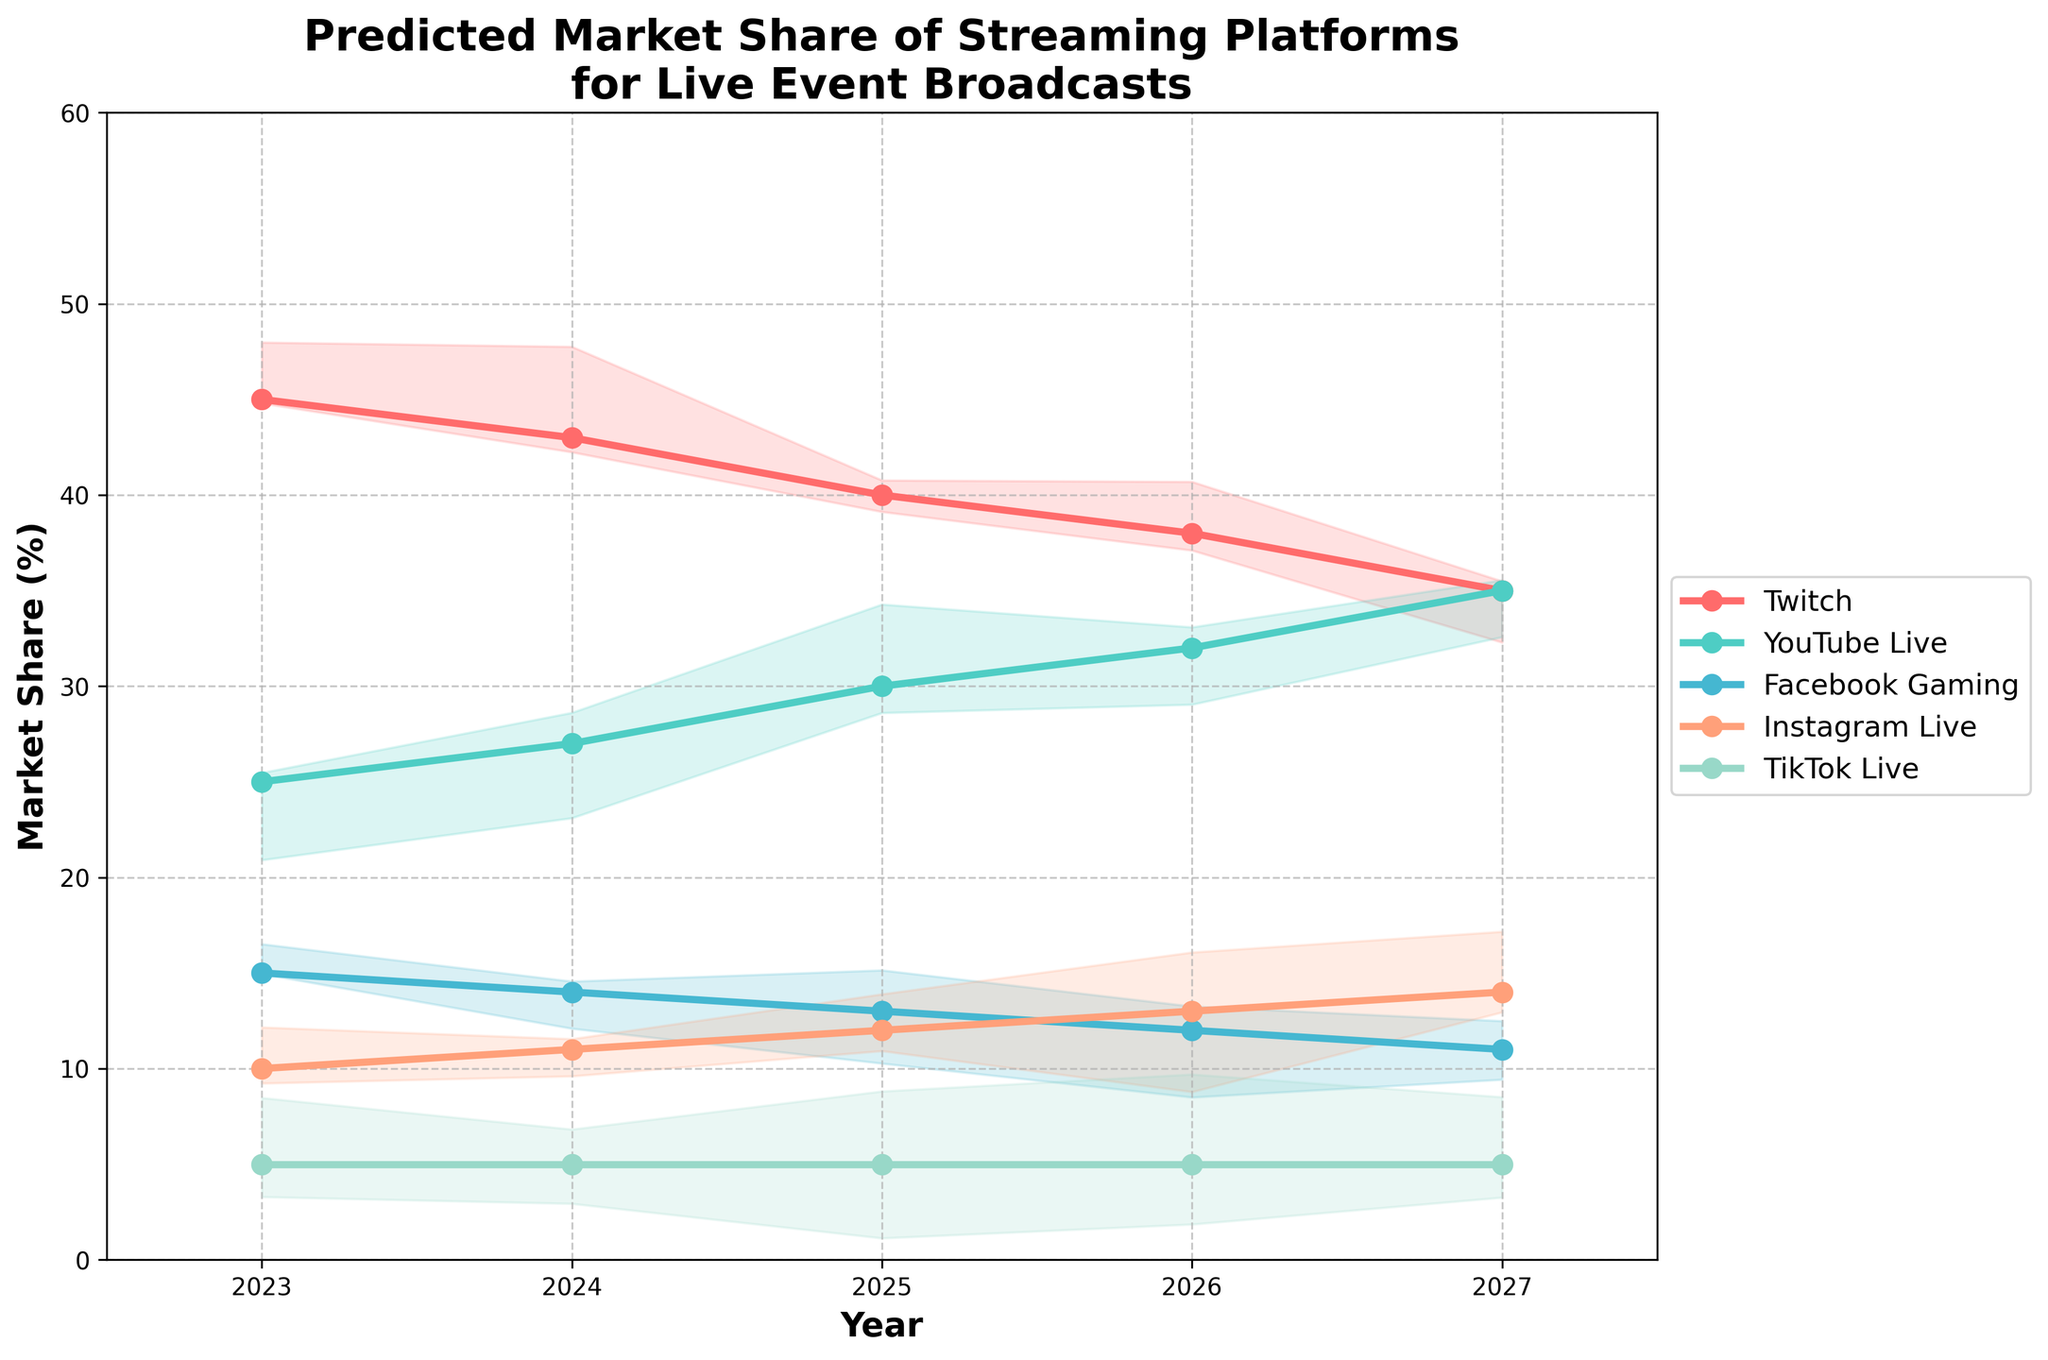What's the title of the figure? The title is displayed prominently at the top of the figure. It is written to convey the main subject of the plot.
Answer: Predicted Market Share of Streaming Platforms for Live Event Broadcasts Which year has the highest predicted market share for YouTube Live? By looking at the line corresponding to YouTube Live and identifying the highest point on the vertical axis, we determine the year.
Answer: 2027 What is the difference in market share between Twitch and Facebook Gaming in 2024? First, locate the market share values for Twitch and Facebook Gaming for the year 2024. Then subtract the market share of Facebook Gaming from that of Twitch. For 2024, Twitch is at 43% and Facebook Gaming is at 14%. Therefore, 43 - 14 = 29.
Answer: 29 Which streaming platform is predicted to maintain a constant market share of 5% throughout the years? By observing the lines associated with each streaming platform, we identify the one that stays flat at 5% for all years.
Answer: TikTok Live By how much does Instagram Live's market share increase from 2023 to 2027? Find the values at 2023 and 2027 for Instagram Live. The value in 2023 is 10%, and in 2027 it is 14%. Therefore, 14 - 10 = 4.
Answer: 4 Which platform is expected to have the largest decrease in market share from 2023 to 2027? Identify the starting and ending market share values for each platform from 2023 to 2027. Calculate the decrease for each and determine the largest reduction. Twitch drops from 45% to 35%, a decrease of 10%.
Answer: Twitch Compare the market share trends of Twitch and YouTube Live. Which platform is expected to surpass the other, and in which year? By examining the intersection points of their lines, we find when YouTube Live’s market share exceeds Twitch’s. This happens in 2026 when YouTube Live becomes higher than Twitch.
Answer: YouTube Live in 2026 What general trend can be observed for Facebook Gaming's market share from 2023 to 2027? Examine the line representing Facebook Gaming over these years and note whether it increases, decreases, or remains stable. The trend shows a gradual decrease.
Answer: Decreasing 